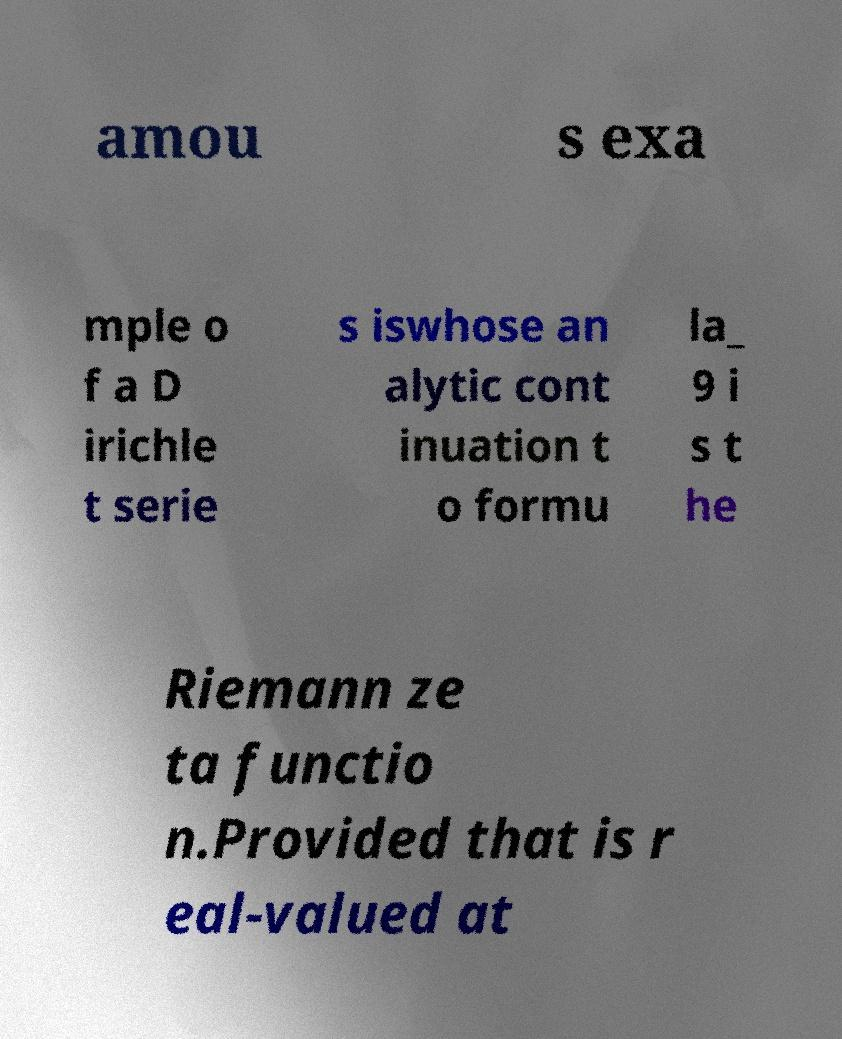Could you extract and type out the text from this image? amou s exa mple o f a D irichle t serie s iswhose an alytic cont inuation t o formu la_ 9 i s t he Riemann ze ta functio n.Provided that is r eal-valued at 